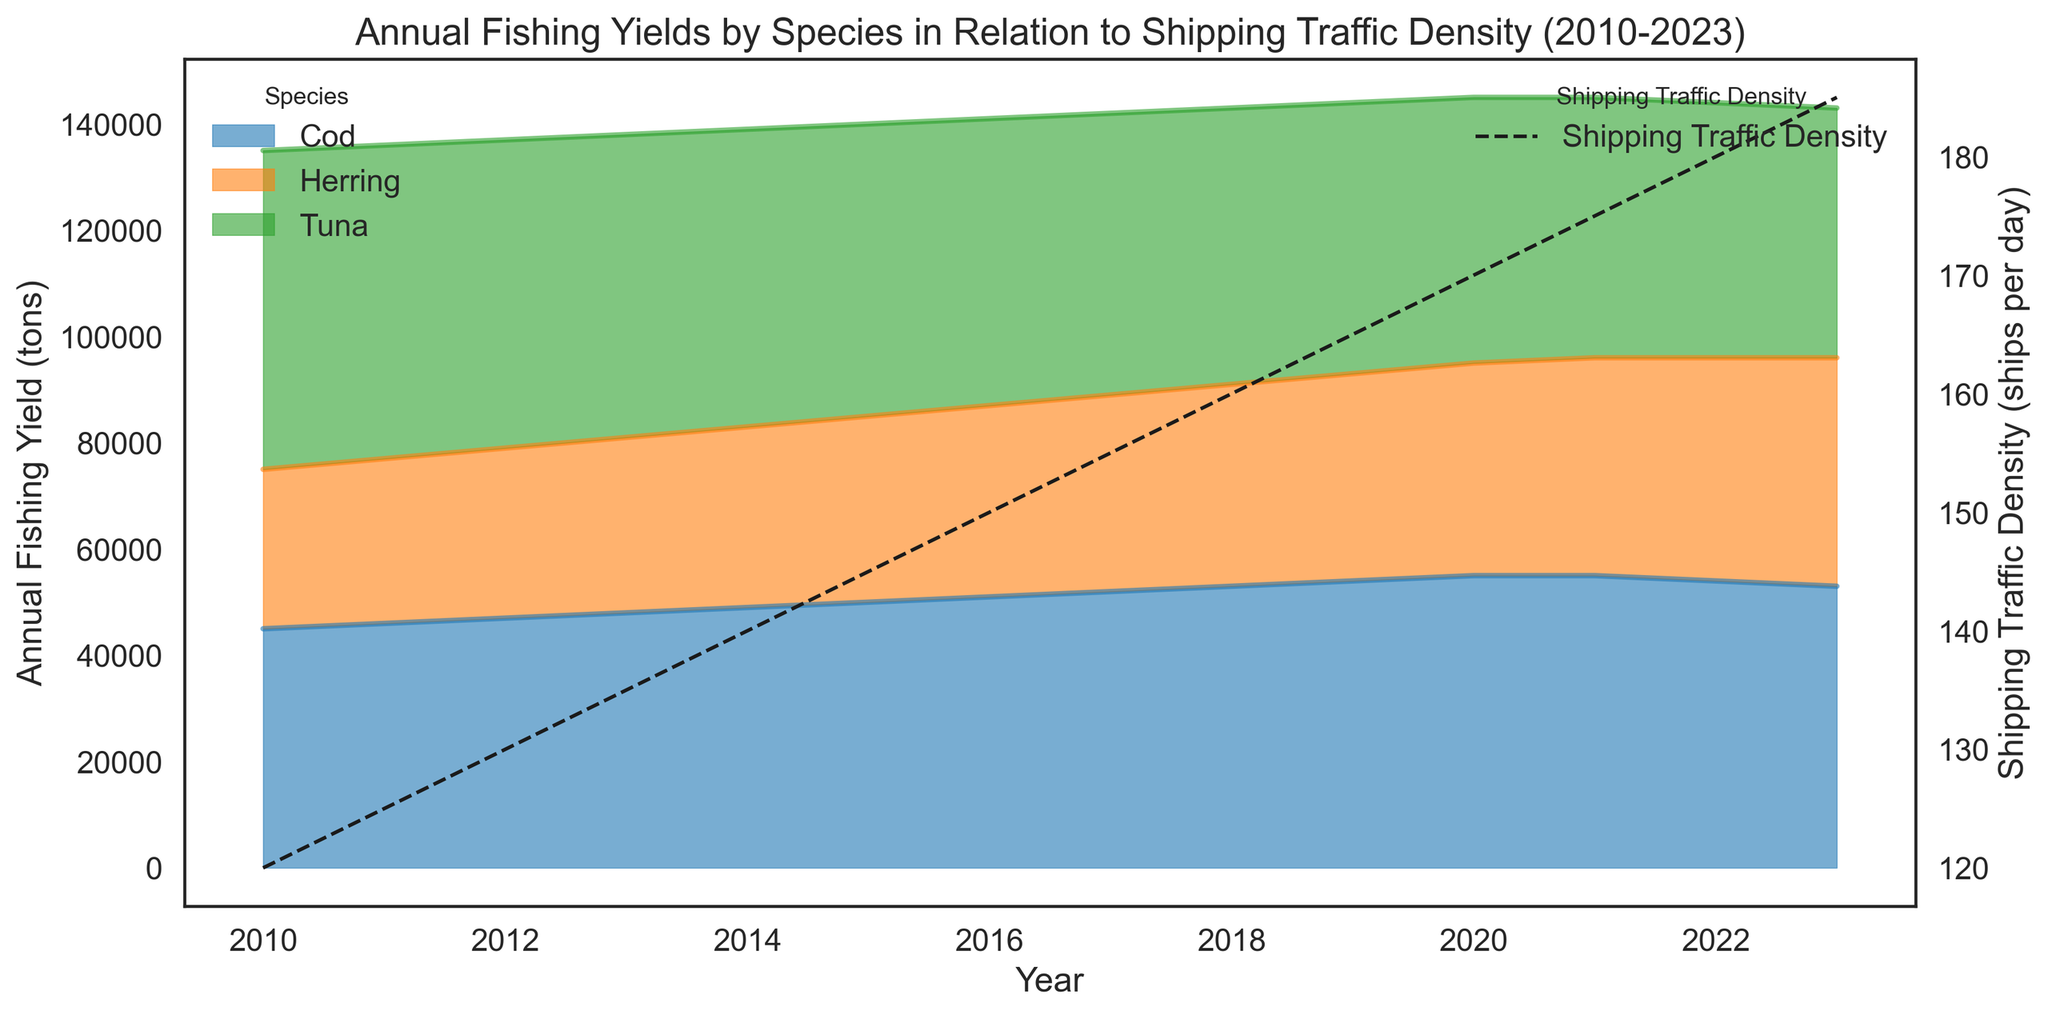What is the overall trend for Cod fishing yield from 2010 to 2023? The Cod fishing yield shows a steady increase from 2010 to 2020, peaking at 55,000 tons, followed by a slight decrease till 2023. The trend is represented by the area chart for Cod.
Answer: Steady increase, then slight decrease How does the fishing yield of Herring in 2010 compare to its yield in 2023? Referring to the area portions for Herring in 2010 and 2023, Herring yield increased from 30,000 tons in 2010 to 43,000 tons in 2023.
Answer: Increased from 30,000 to 43,000 tons Which species had the highest fishing yield in 2020? By examining the peak points of each species in 2020, Cod had the highest yield at 55,000 tons.
Answer: Cod What is the relationship between Shipping Traffic Density and Tuna fishing yield over the years? Observing the dashed line for Shipping Traffic Density and the area for Tuna, as Shipping Traffic Density increased from 120 ships per day in 2010 to 185 in 2023, Tuna fishing yield decreased from 60,000 tons to 47,000 tons.
Answer: Inverse relationship When did the maximum shipping traffic density occur, and what was the density then? The dashed line for Shipping Traffic Density reaches its peak in 2023, at 185 ships per day.
Answer: 2023, 185 ships per day How did the combined fishing yield of all species change from 2015 to 2018? Summing the yields for Cod, Tuna, and Herring for both years, 2015: 50,000 + 55,000 + 35,000 = 140,000 tons, and 2018: 53,000 + 52,000 + 38,000 = 143,000 tons, showing an increase.
Answer: Increased from 140,000 to 143,000 tons What is the general trend shown for shipping traffic density from 2010 to 2023? The dashed line indicating shipping traffic density shows a consistent increase from 120 ships per day in 2010 up to 185 per day in 2023.
Answer: Consistent increase How does the Cod fishing yield in 2015 compare to its yield in 2020? Referring to the area portions for Cod, it increases from 50,000 tons in 2015 to 55,000 tons in 2020.
Answer: Increased from 50,000 to 55,000 tons 